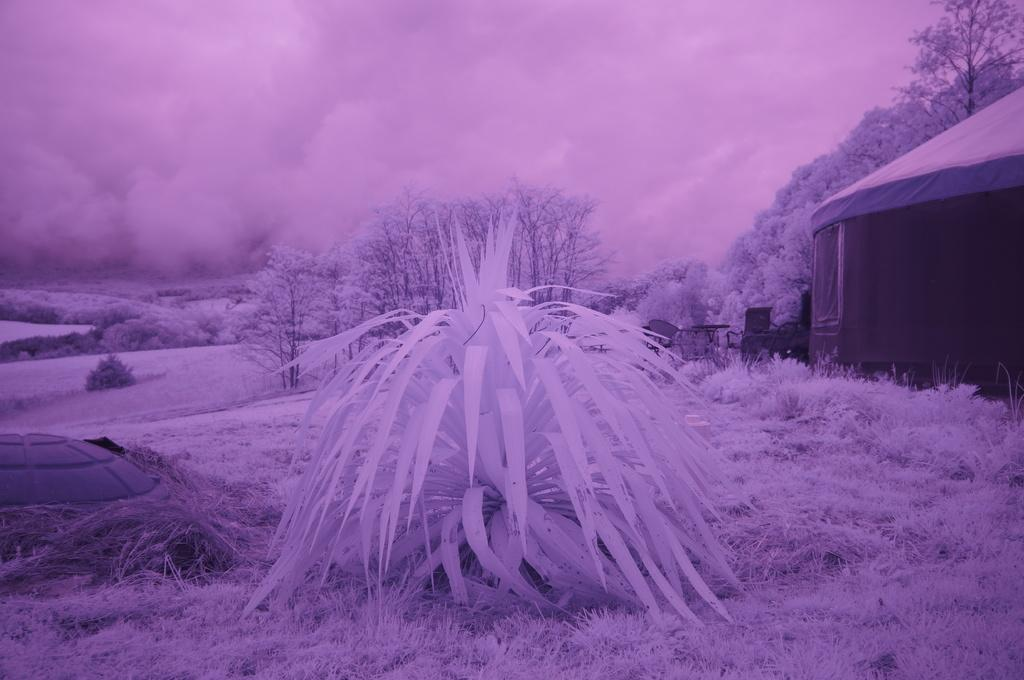What type of vegetation is present in the image? There are trees and grass in the image. What structure can be seen on the right side of the image? There appears to be a tent on the right side of the image. What is the overall color of the image? The image has a purple color. How many twigs are visible in the image? There is no mention of twigs in the image, so it is impossible to determine their number. What is the mass of the tent in the image? The mass of the tent cannot be determined from the image alone, as it would require additional information or context. 